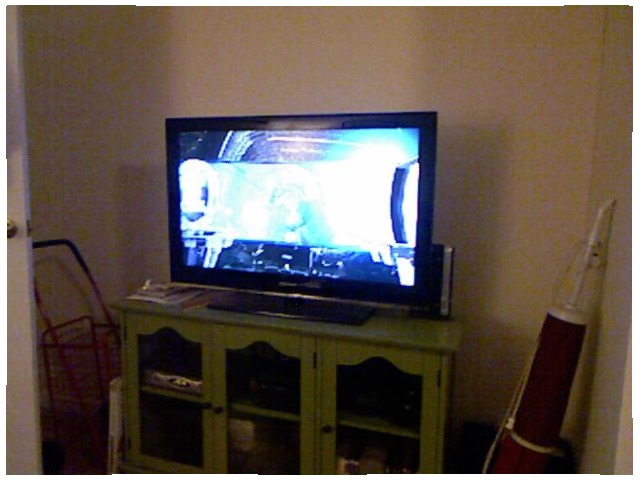<image>
Can you confirm if the tv is in front of the wall? Yes. The tv is positioned in front of the wall, appearing closer to the camera viewpoint. Where is the vacuum cleaner in relation to the wall? Is it on the wall? Yes. Looking at the image, I can see the vacuum cleaner is positioned on top of the wall, with the wall providing support. Is the television on the cabinet? Yes. Looking at the image, I can see the television is positioned on top of the cabinet, with the cabinet providing support. Is the television on the build? No. The television is not positioned on the build. They may be near each other, but the television is not supported by or resting on top of the build. 